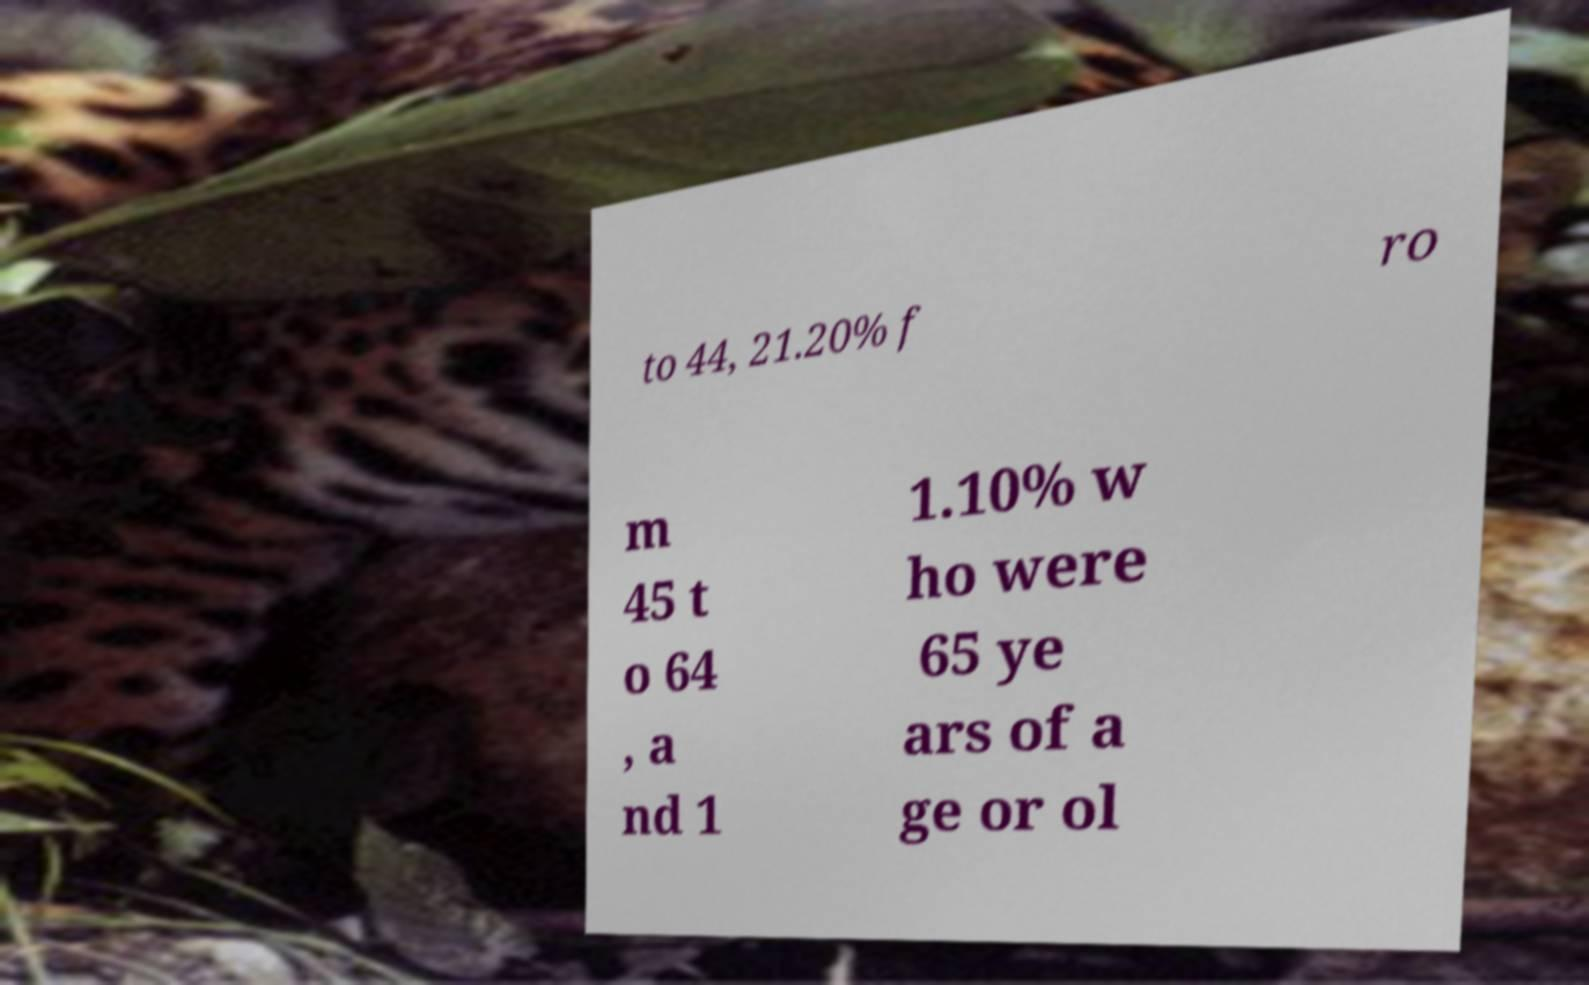Can you read and provide the text displayed in the image?This photo seems to have some interesting text. Can you extract and type it out for me? to 44, 21.20% f ro m 45 t o 64 , a nd 1 1.10% w ho were 65 ye ars of a ge or ol 